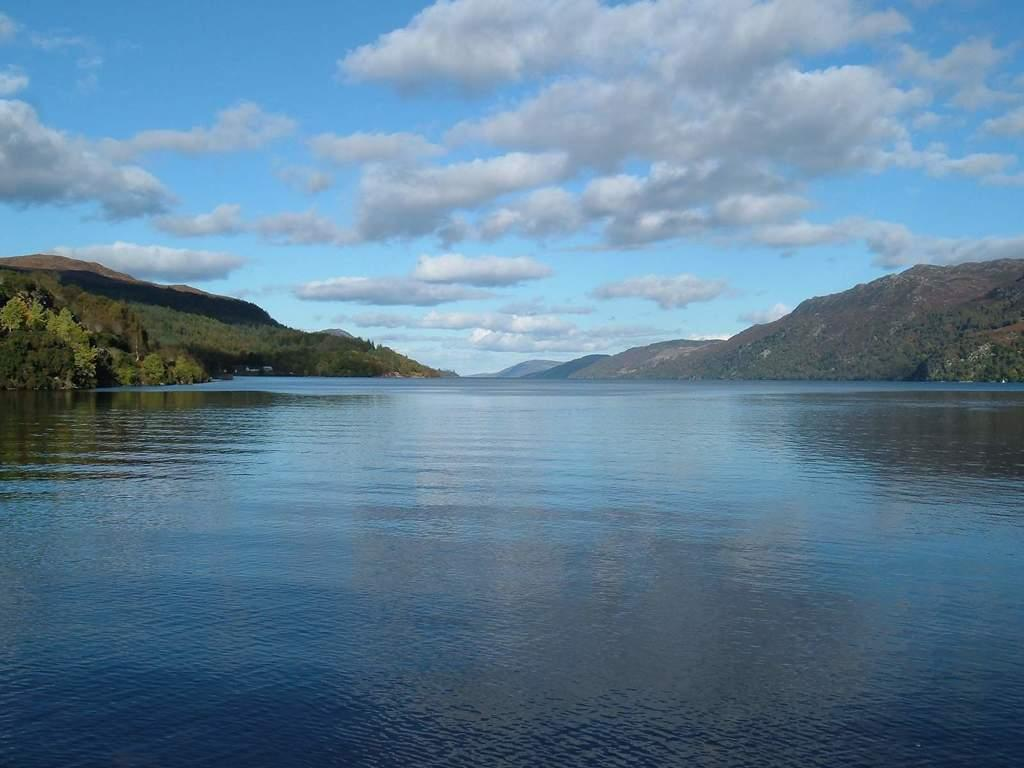What natural element is visible in the image? Water is visible in the image. What type of geographical feature can be seen in the image? There are hills in the image. What type of vegetation is present in the image? There are trees in the image. What is the condition of the sky in the image? The sky is cloudy in the image. Where is the cemetery located in the image? There is no cemetery present in the image. What type of meat can be seen hanging from the trees in the image? There is no meat present in the image; it features water, hills, and trees. What type of calculator is visible on the hills in the image? There is no calculator present in the image. 